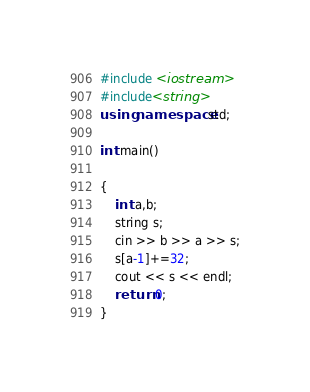<code> <loc_0><loc_0><loc_500><loc_500><_C++_>#include <iostream>
#include<string>
using namespace std;

int main()

{
    int a,b;
    string s;
    cin >> b >> a >> s;
    s[a-1]+=32;
    cout << s << endl;
    return 0;
}
</code> 